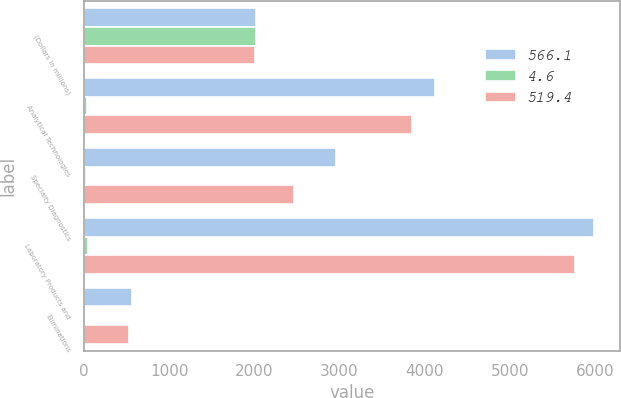Convert chart. <chart><loc_0><loc_0><loc_500><loc_500><stacked_bar_chart><ecel><fcel>(Dollars in millions)<fcel>Analytical Technologies<fcel>Specialty Diagnostics<fcel>Laboratory Products and<fcel>Eliminations<nl><fcel>566.1<fcel>2012<fcel>4123.7<fcel>2962.3<fcel>5990<fcel>566.1<nl><fcel>4.6<fcel>2012<fcel>33<fcel>23.7<fcel>47.9<fcel>4.6<nl><fcel>519.4<fcel>2011<fcel>3845.4<fcel>2469.9<fcel>5762.9<fcel>519.4<nl></chart> 